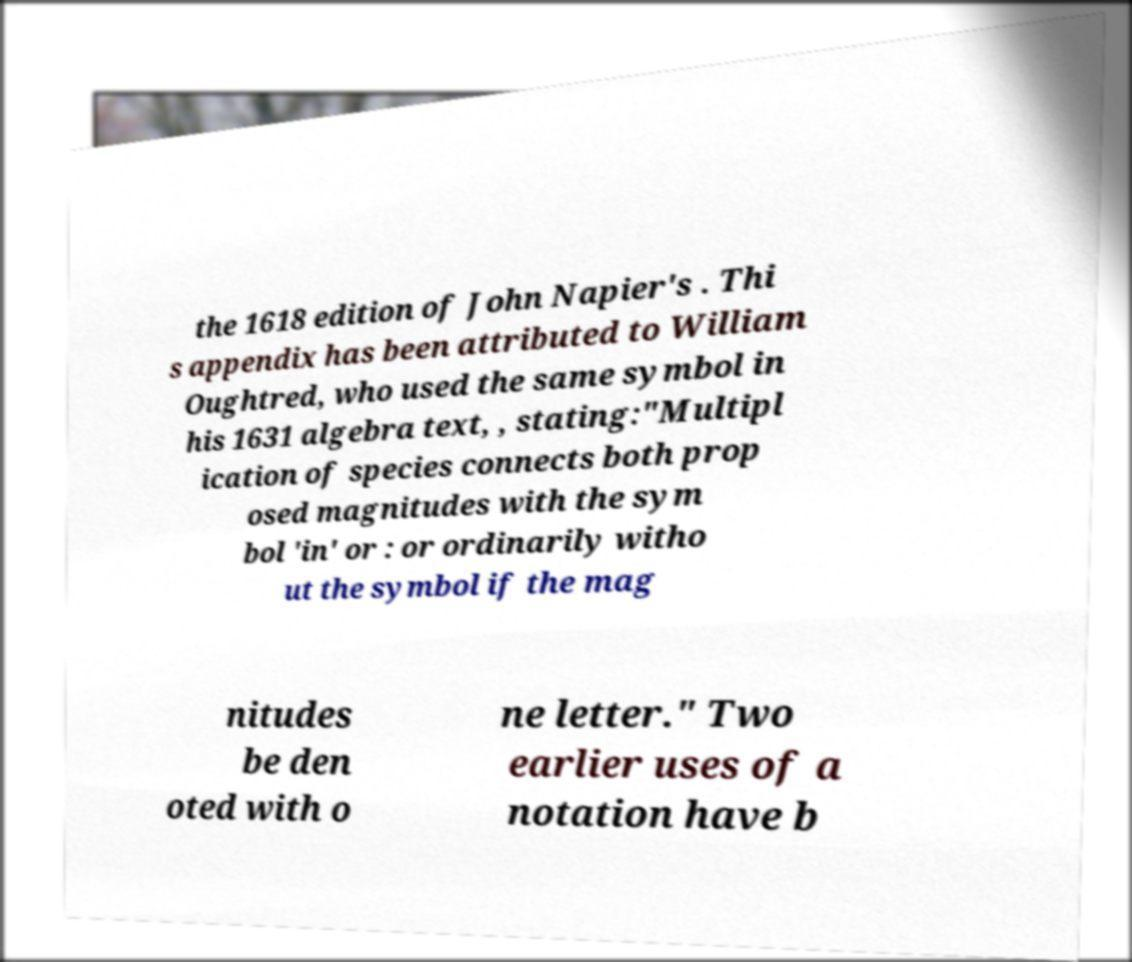I need the written content from this picture converted into text. Can you do that? the 1618 edition of John Napier's . Thi s appendix has been attributed to William Oughtred, who used the same symbol in his 1631 algebra text, , stating:"Multipl ication of species connects both prop osed magnitudes with the sym bol 'in' or : or ordinarily witho ut the symbol if the mag nitudes be den oted with o ne letter." Two earlier uses of a notation have b 